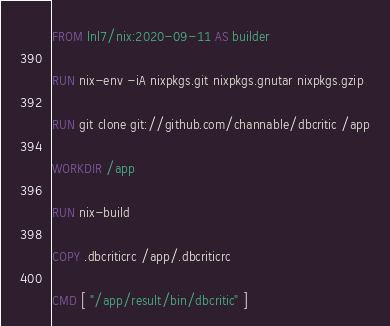Convert code to text. <code><loc_0><loc_0><loc_500><loc_500><_Dockerfile_>FROM lnl7/nix:2020-09-11 AS builder

RUN nix-env -iA nixpkgs.git nixpkgs.gnutar nixpkgs.gzip

RUN git clone git://github.com/channable/dbcritic /app

WORKDIR /app

RUN nix-build

COPY .dbcriticrc /app/.dbcriticrc

CMD [ "/app/result/bin/dbcritic" ]
</code> 